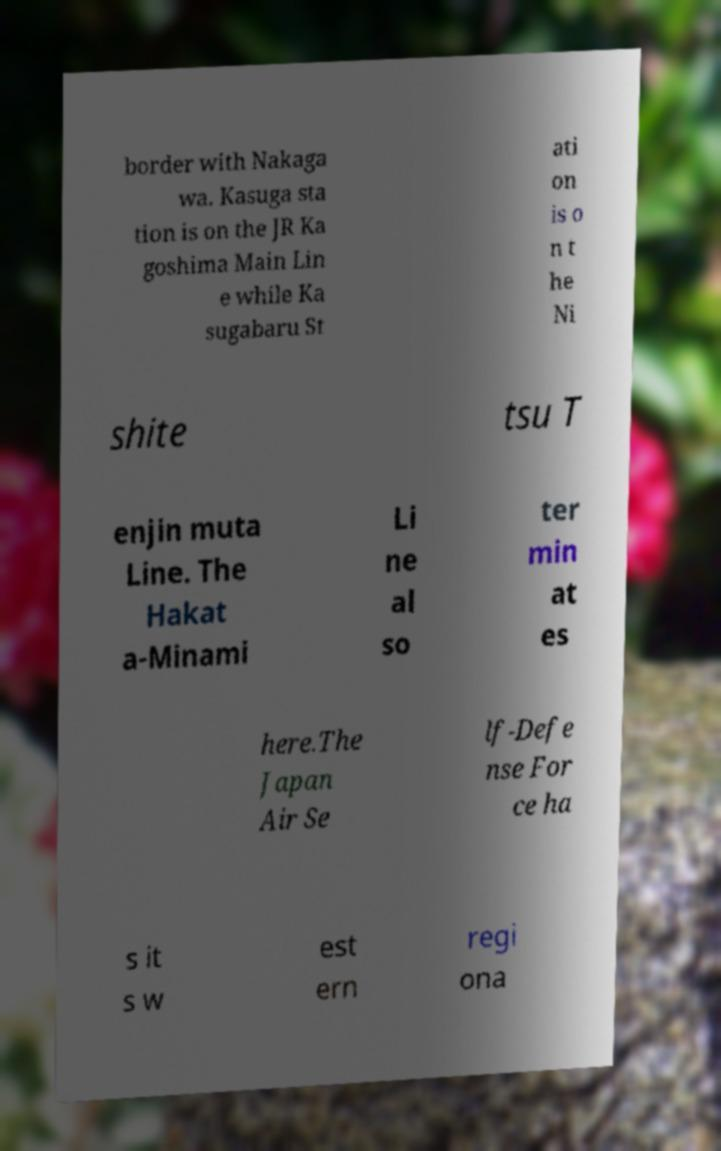What messages or text are displayed in this image? I need them in a readable, typed format. border with Nakaga wa. Kasuga sta tion is on the JR Ka goshima Main Lin e while Ka sugabaru St ati on is o n t he Ni shite tsu T enjin muta Line. The Hakat a-Minami Li ne al so ter min at es here.The Japan Air Se lf-Defe nse For ce ha s it s w est ern regi ona 